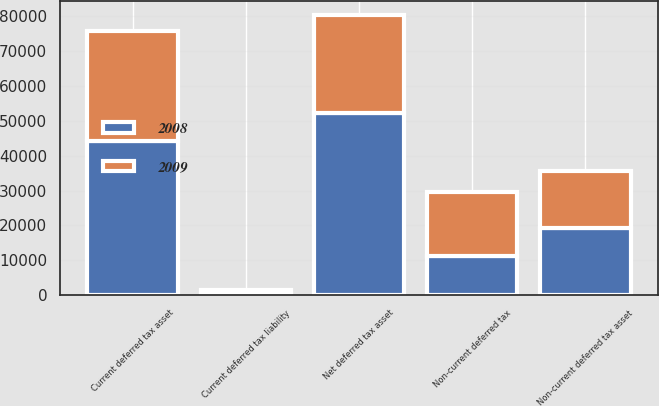<chart> <loc_0><loc_0><loc_500><loc_500><stacked_bar_chart><ecel><fcel>Current deferred tax asset<fcel>Non-current deferred tax asset<fcel>Current deferred tax liability<fcel>Non-current deferred tax<fcel>Net deferred tax asset<nl><fcel>2008<fcel>44368<fcel>19364<fcel>391<fcel>11137<fcel>52204<nl><fcel>2009<fcel>31355<fcel>16162<fcel>1150<fcel>18333<fcel>28034<nl></chart> 